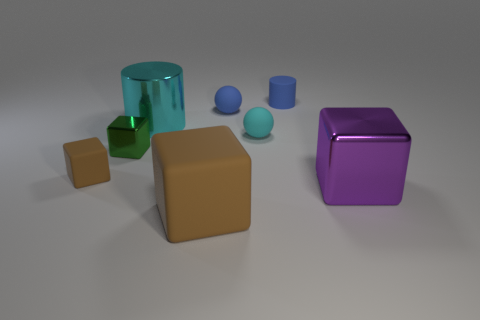Subtract 1 blocks. How many blocks are left? 3 Add 1 balls. How many objects exist? 9 Subtract all spheres. How many objects are left? 6 Subtract 0 green balls. How many objects are left? 8 Subtract all tiny blue blocks. Subtract all small green things. How many objects are left? 7 Add 8 small brown matte blocks. How many small brown matte blocks are left? 9 Add 6 small gray cylinders. How many small gray cylinders exist? 6 